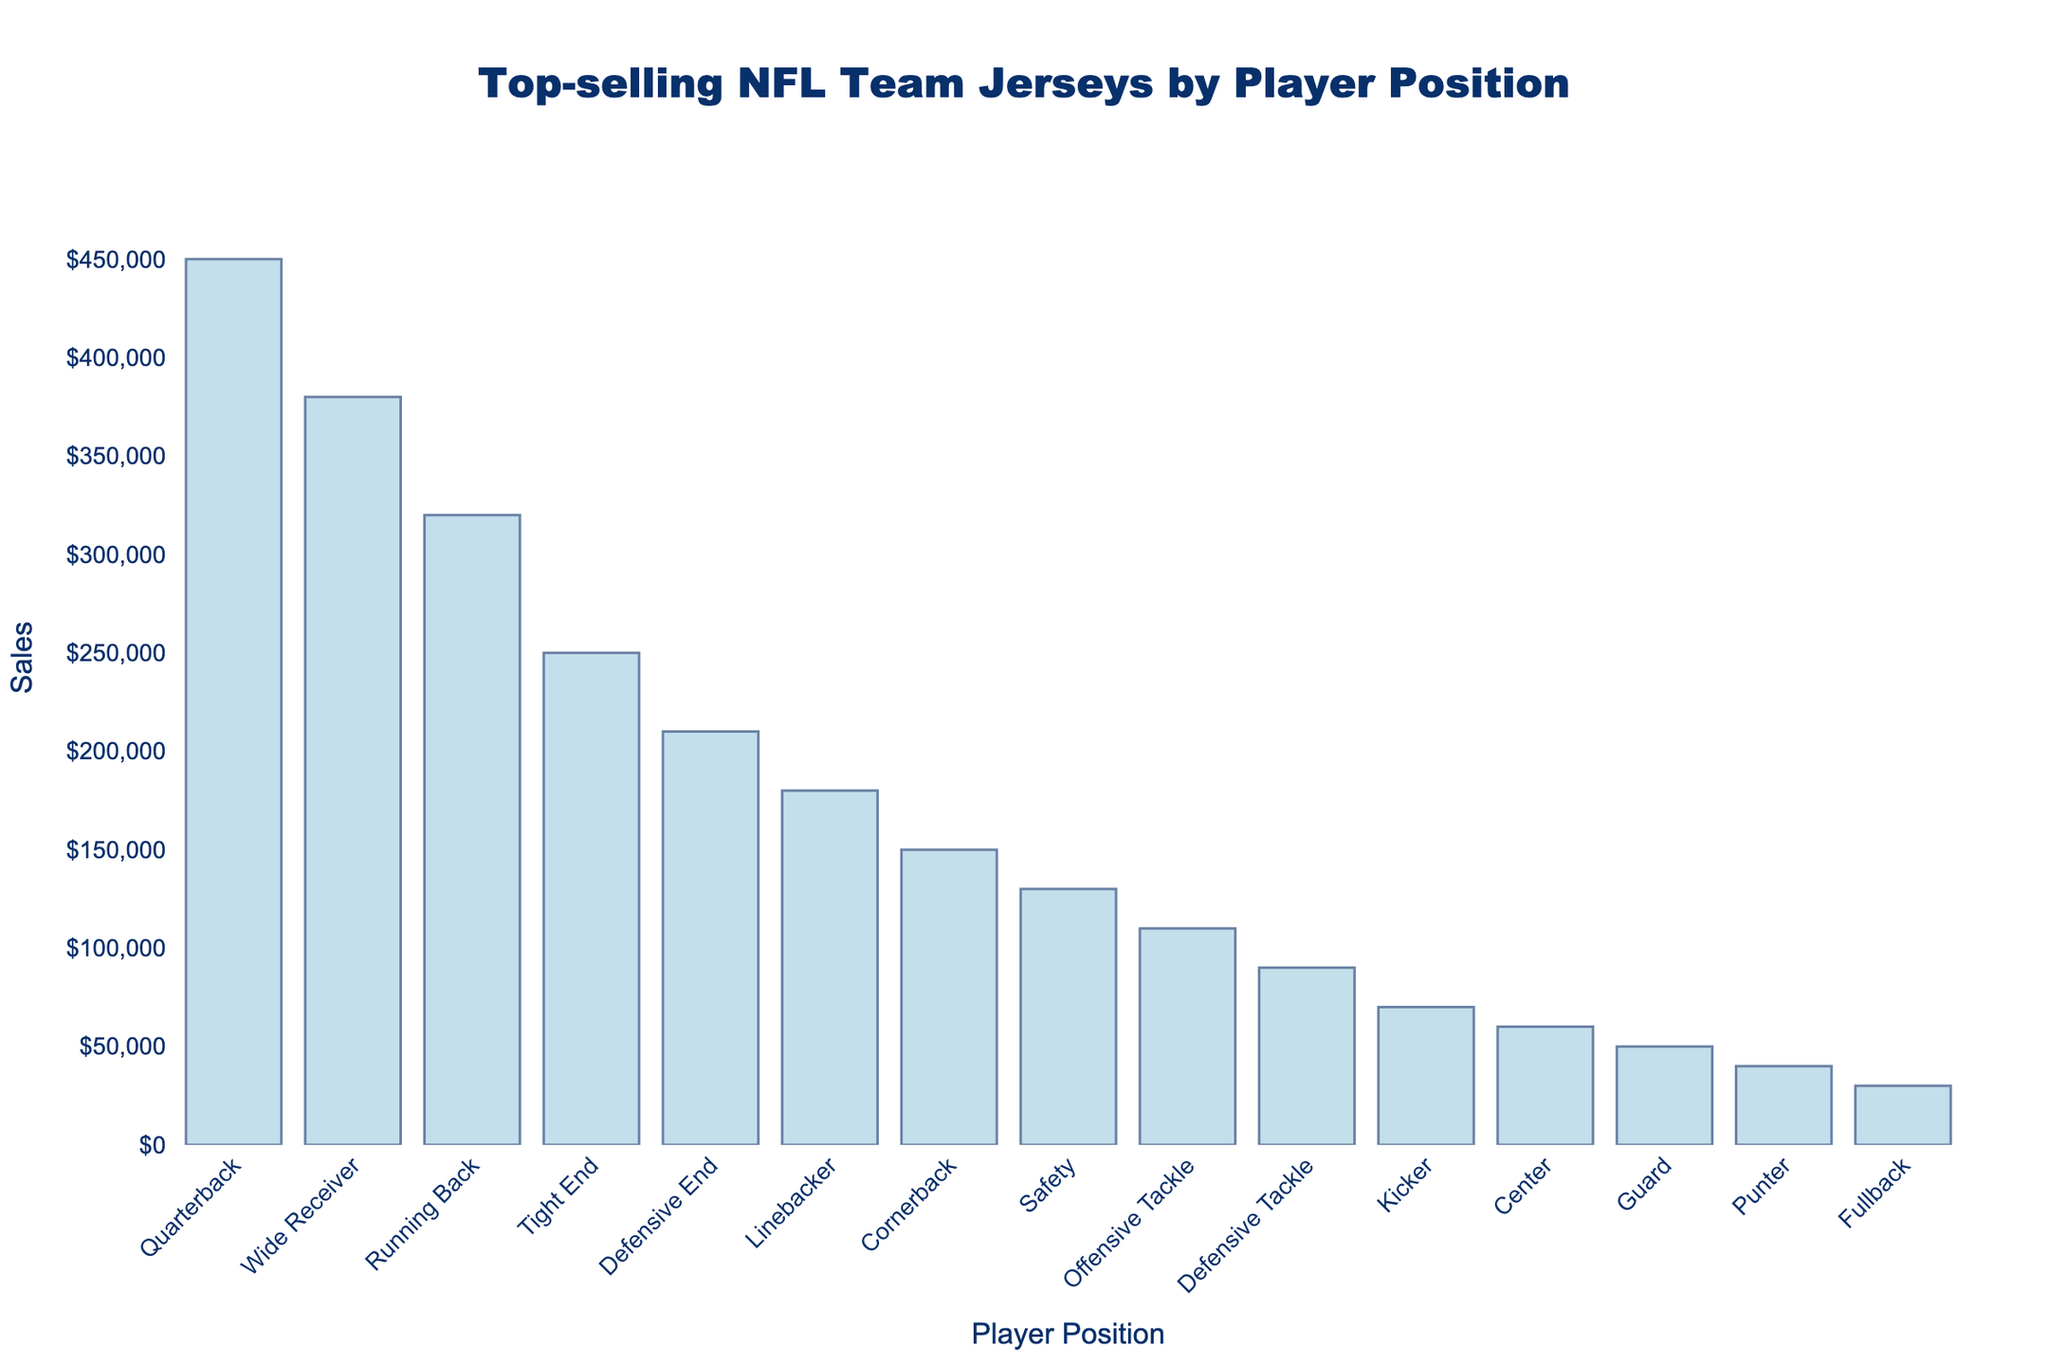Which player position has the highest jersey sales? The bar representing the "Quarterback" position is the tallest, indicating the highest sales.
Answer: Quarterback What’s the difference in jersey sales between Quarterbacks and Linebackers? The sales for Quarterbacks are 450,000, and for Linebackers, it is 180,000. The difference is 450,000 - 180,000.
Answer: 270,000 Is the number of jersey sales for Wide Receivers greater than the combined sales for Linebackers and Defensive Ends? The sales for Wide Receivers are 380,000. For Linebackers, it is 180,000, and for Defensive Ends, it is 210,000. Adding the latter two sales gives 180,000 + 210,000 = 390,000, which is greater than 380,000.
Answer: No Which player positions have the lowest jersey sales, and what are their figures? The bars representing "Fullback" and "Punter" are the shortest, indicating the lowest sales. Fullback has 30,000, and Punter has 40,000.
Answer: Fullback (30,000) and Punter (40,000) By how much do Tight End jersey sales exceed those of Center jersey sales? The sales for Tight Ends are 250,000, and for Centers, it is 60,000. The difference is 250,000 - 60,000.
Answer: 190,000 Rank the top three positions in terms of jersey sales. The heights of the bars indicate the order of sales. Quarterbacks are first, followed by Wide Receivers, then Running Backs.
Answer: Quarterback, Wide Receiver, Running Back Are the total jersey sales for Defensive players (Defensive End, Linebacker, Cornerback, Safety, Defensive Tackle) greater than those for Offensive players (Quarterback, Wide Receiver, Running Back, Tight End, Offensive Tackle, Center, Guard, Fullback)? Add the sales for Defensive players: 210,000 (End) + 180,000 (Linebacker) + 150,000 (Cornerback) + 130,000 (Safety) + 90,000 (Tackle) = 760,000. Add the sales for Offensive players: 450,000 (Quarterback) + 380,000 (Receiver) + 320,000 (Running Back) + 250,000 (Tight End) + 110,000 (Tackle) + 60,000 (Center) + 50,000 (Guard) + 30,000 (Fullback) = 1,650,000. 760,000 is less than 1,650,000.
Answer: No Which position has sales closest to 100,000? The bar for Offensive Tackle is slightly above the 100,000 mark, closer than any other position.
Answer: Offensive Tackle What is the total jersey sales for Special Teams players (Kicker, Punter)? The sales are 70,000 for Kicker and 40,000 for Punter. The total is 70,000 + 40,000.
Answer: 110,000 How many times higher are Quarterback jersey sales compared to Fullback jersey sales? Quarterback sales are 450,000, and Fullback sales are 30,000. The ratio is 450,000 / 30,000.
Answer: 15 times 